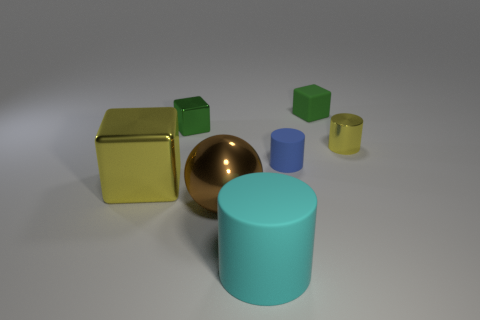Is the cyan matte thing the same shape as the blue object?
Your answer should be very brief. Yes. There is a brown metallic thing; how many yellow metal blocks are in front of it?
Offer a terse response. 0. There is a big yellow object in front of the small green thing that is to the right of the brown metal object; what shape is it?
Provide a succinct answer. Cube. The other tiny thing that is the same material as the tiny blue object is what shape?
Offer a very short reply. Cube. Do the cube in front of the yellow cylinder and the green cube that is to the right of the small green shiny cube have the same size?
Give a very brief answer. No. There is a yellow thing that is behind the large shiny cube; what is its shape?
Ensure brevity in your answer.  Cylinder. What is the color of the matte block?
Your answer should be very brief. Green. Is the size of the yellow shiny cylinder the same as the yellow shiny thing that is in front of the small yellow metal cylinder?
Provide a succinct answer. No. What number of metallic things are large yellow cubes or large red spheres?
Give a very brief answer. 1. Are there any other things that are the same material as the small yellow cylinder?
Keep it short and to the point. Yes. 